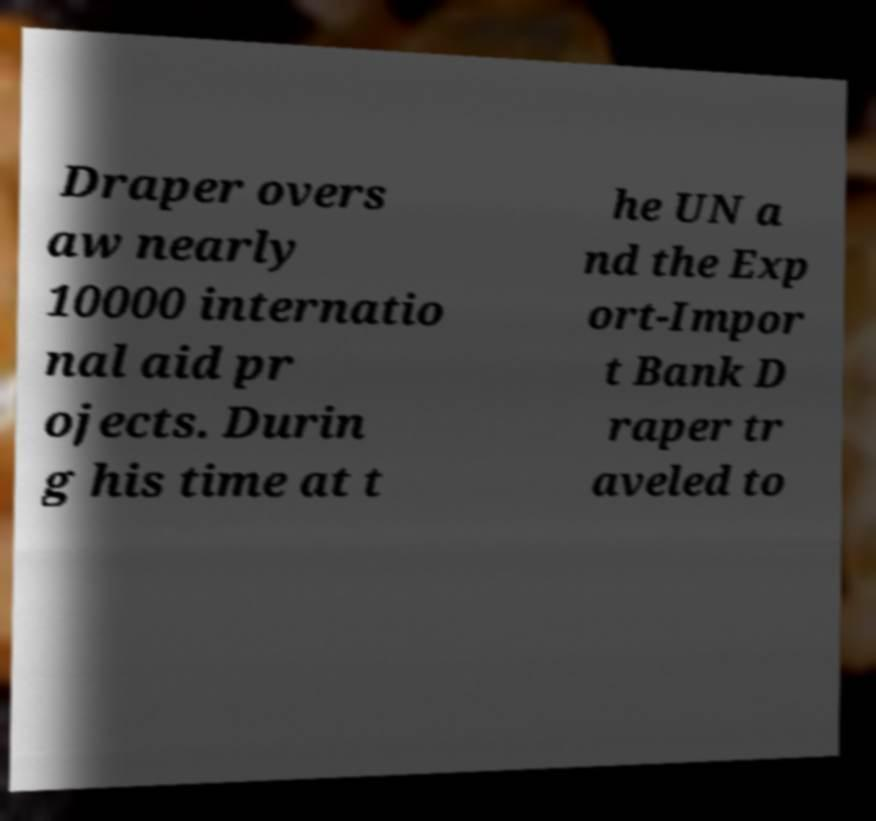Please identify and transcribe the text found in this image. Draper overs aw nearly 10000 internatio nal aid pr ojects. Durin g his time at t he UN a nd the Exp ort-Impor t Bank D raper tr aveled to 